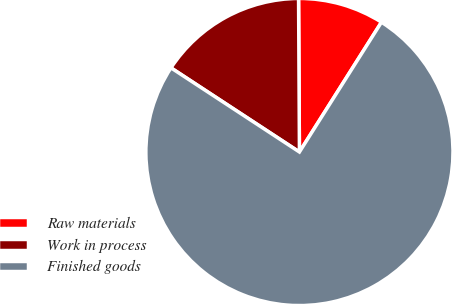<chart> <loc_0><loc_0><loc_500><loc_500><pie_chart><fcel>Raw materials<fcel>Work in process<fcel>Finished goods<nl><fcel>9.06%<fcel>15.68%<fcel>75.26%<nl></chart> 